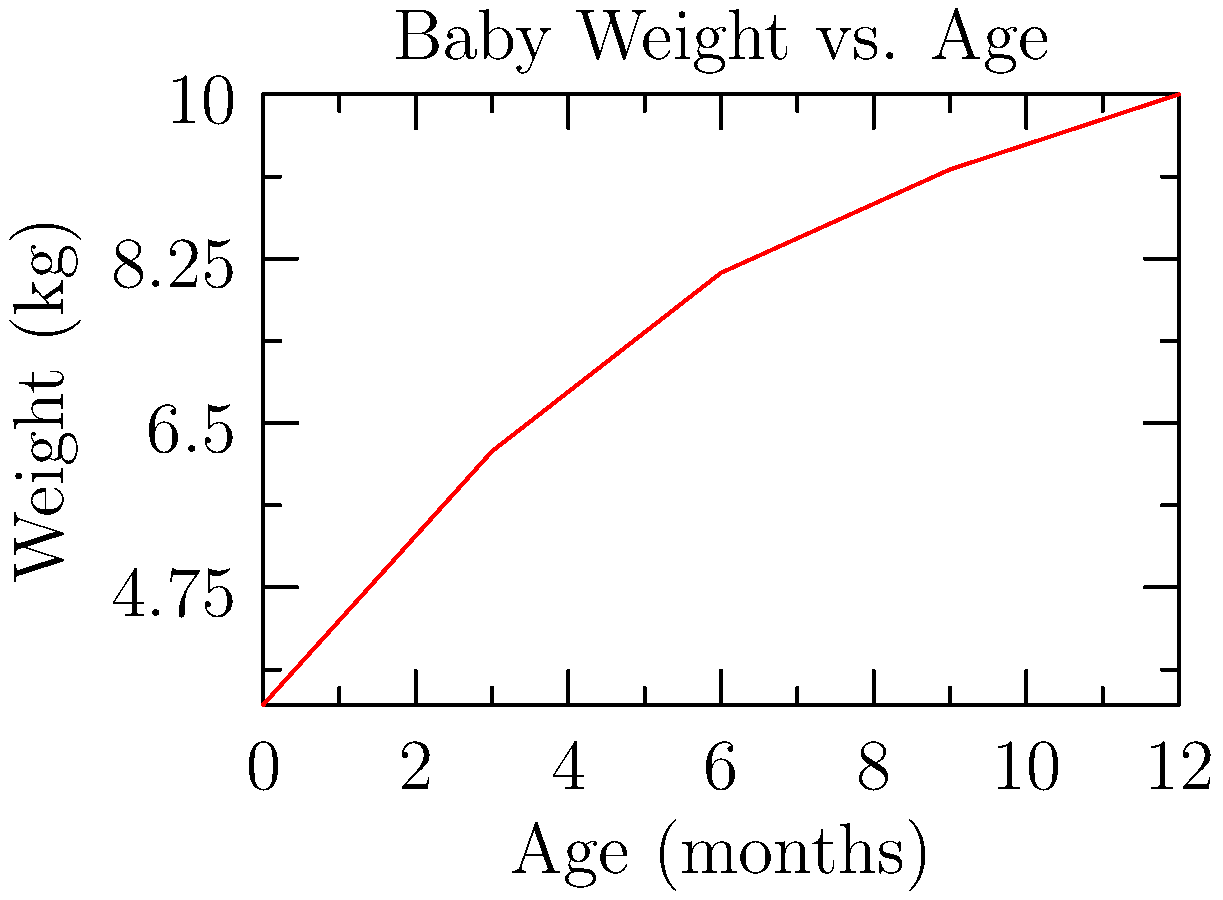The graph shows the average weight of a baby from birth to 12 months. If the force required to lift an object is equal to its weight multiplied by the acceleration due to gravity (9.8 m/s²), how much more force (in Newtons) is needed to lift a 12-month-old baby compared to a newborn? To solve this problem, we'll follow these steps:

1. Identify the weights:
   - Newborn (0 months): 3.5 kg
   - 12-month-old: 10 kg

2. Calculate the force needed for each:
   Force = mass × acceleration due to gravity
   $F = m × 9.8$ m/s²

   For newborn:
   $F_{newborn} = 3.5 × 9.8 = 34.3$ N

   For 12-month-old:
   $F_{12month} = 10 × 9.8 = 98$ N

3. Calculate the difference:
   $\Delta F = F_{12month} - F_{newborn}$
   $\Delta F = 98 - 34.3 = 63.7$ N

Therefore, 63.7 N more force is needed to lift a 12-month-old baby compared to a newborn.
Answer: 63.7 N 